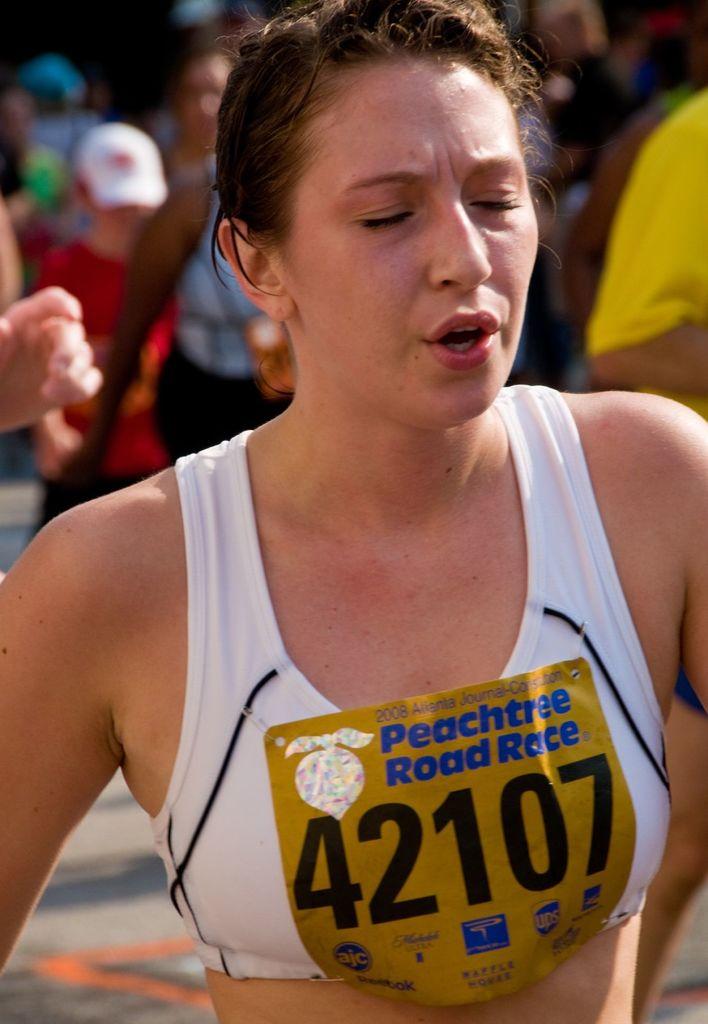What is the name of the race that this woman is competing in?
Your response must be concise. Peachtree road race. What is the racer's number?
Give a very brief answer. 42107. 